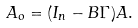<formula> <loc_0><loc_0><loc_500><loc_500>A _ { o } = ( I _ { n } - B \Gamma ) A .</formula> 